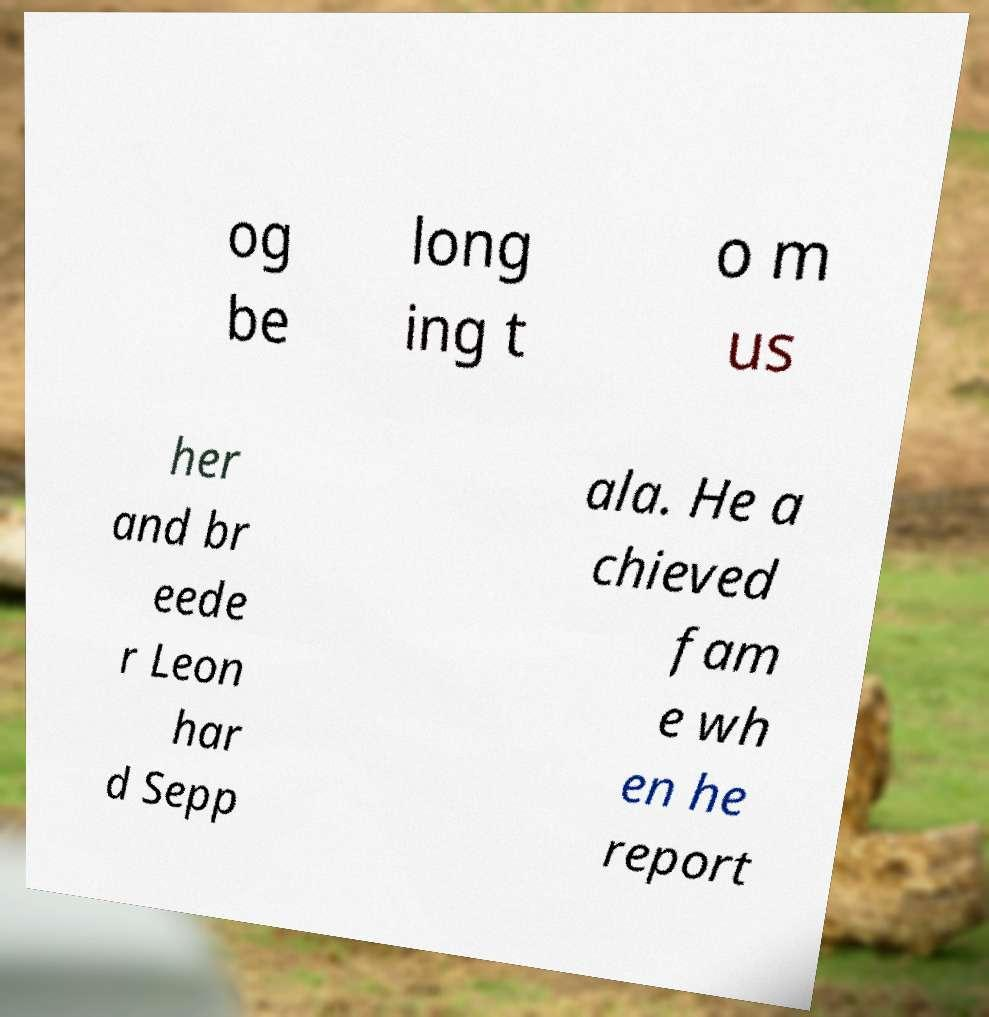Can you read and provide the text displayed in the image?This photo seems to have some interesting text. Can you extract and type it out for me? og be long ing t o m us her and br eede r Leon har d Sepp ala. He a chieved fam e wh en he report 